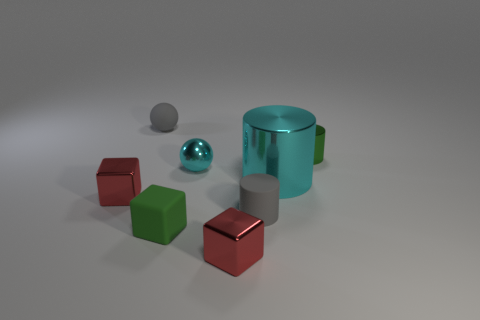Are there any small shiny cylinders that have the same color as the rubber block?
Offer a very short reply. Yes. Does the matte thing that is behind the large cyan metal object have the same color as the matte cylinder?
Your response must be concise. Yes. There is a cylinder that is the same color as the tiny matte cube; what is its material?
Ensure brevity in your answer.  Metal. What size is the rubber cylinder that is the same color as the rubber ball?
Provide a succinct answer. Small. There is a cylinder on the right side of the big cylinder; is it the same color as the matte object in front of the gray cylinder?
Provide a succinct answer. Yes. How many objects are tiny objects or green rubber things?
Provide a short and direct response. 7. How many other things are the same shape as the tiny green metallic object?
Offer a very short reply. 2. Is the small cylinder that is left of the tiny green metallic cylinder made of the same material as the small block to the right of the small cyan metallic ball?
Your response must be concise. No. The small object that is both to the left of the green block and in front of the large metallic thing has what shape?
Make the answer very short. Cube. What is the material of the block that is both to the right of the tiny gray ball and to the left of the small cyan metallic sphere?
Make the answer very short. Rubber. 